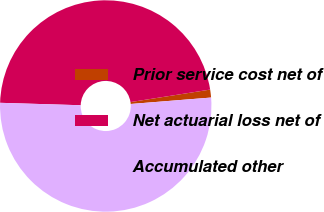Convert chart to OTSL. <chart><loc_0><loc_0><loc_500><loc_500><pie_chart><fcel>Prior service cost net of<fcel>Net actuarial loss net of<fcel>Accumulated other<nl><fcel>1.21%<fcel>47.04%<fcel>51.75%<nl></chart> 